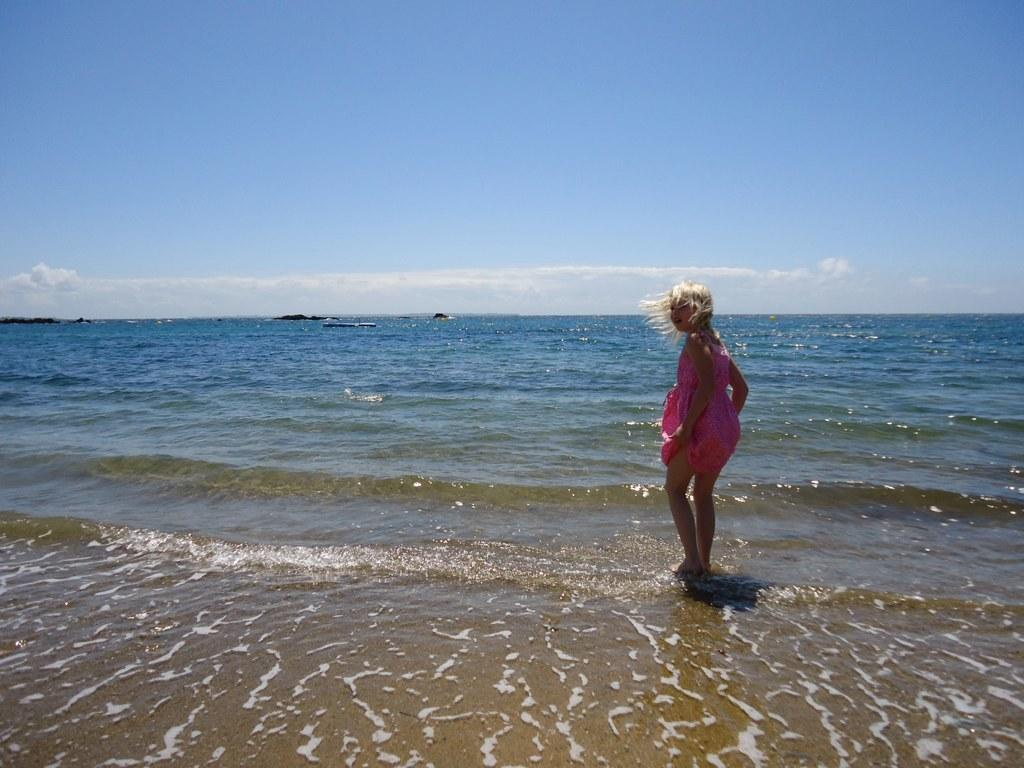What is the girl doing in the image? The girl is standing on water in the image. What can be seen in the background of the image? The sky is visible in the image. What is the condition of the sky in the image? Clouds are present in the sky. What type of fuel is the girl using to stand on water in the image? The girl is not using any fuel to stand on water in the image; it appears to be a supernatural or artistic representation. How does the girl pull off this feat in the image? The image does not provide any information on how the girl is standing on water; it is simply a visual representation. 